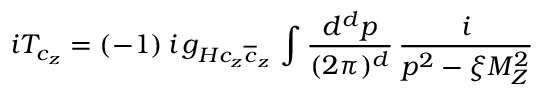<formula> <loc_0><loc_0><loc_500><loc_500>i T _ { c _ { z } } = ( - 1 ) \, i \, g _ { H { c _ { z } } { \overline { c } _ { z } } } \, \int \frac { d ^ { d } p } { ( 2 \pi ) ^ { d } } \, \frac { i } { p ^ { 2 } - \xi M _ { Z } ^ { 2 } }</formula> 